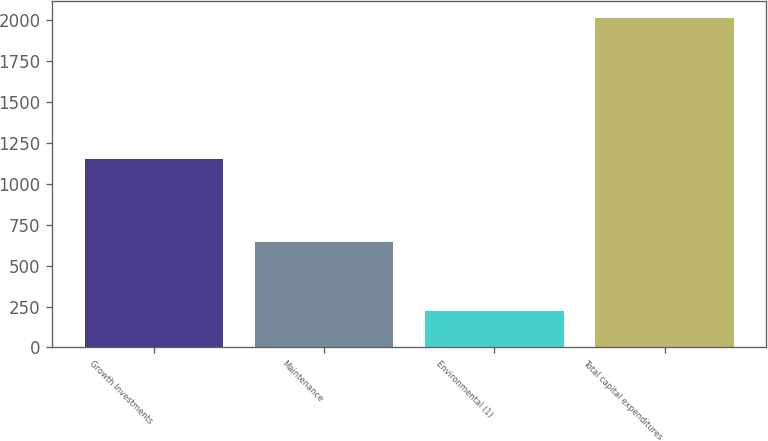Convert chart. <chart><loc_0><loc_0><loc_500><loc_500><bar_chart><fcel>Growth Investments<fcel>Maintenance<fcel>Environmental (1)<fcel>Total capital expenditures<nl><fcel>1151<fcel>645<fcel>220<fcel>2016<nl></chart> 